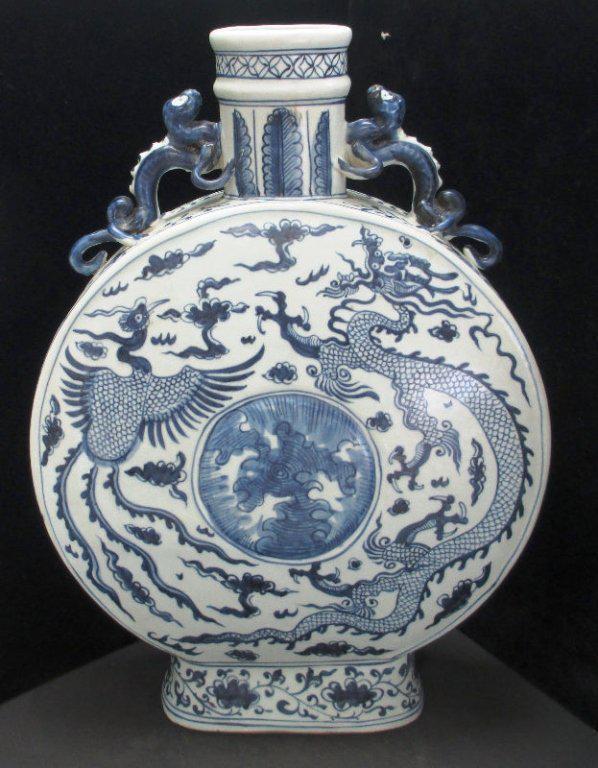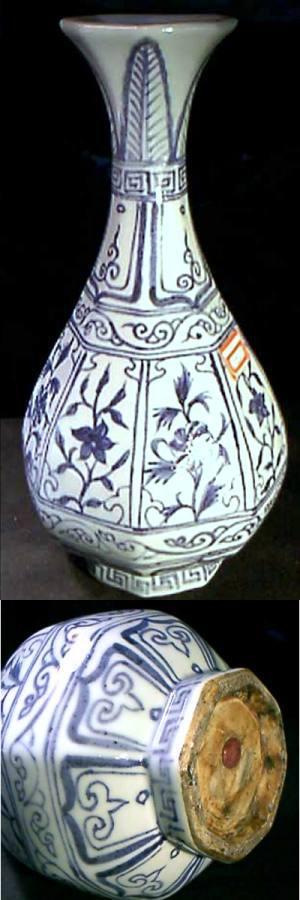The first image is the image on the left, the second image is the image on the right. Examine the images to the left and right. Is the description "In the left image, the artwork appears to include a dragon." accurate? Answer yes or no. Yes. The first image is the image on the left, the second image is the image on the right. Given the left and right images, does the statement "The left image features a vase with a round midsection and a dragon depicted in blue on its front." hold true? Answer yes or no. Yes. 